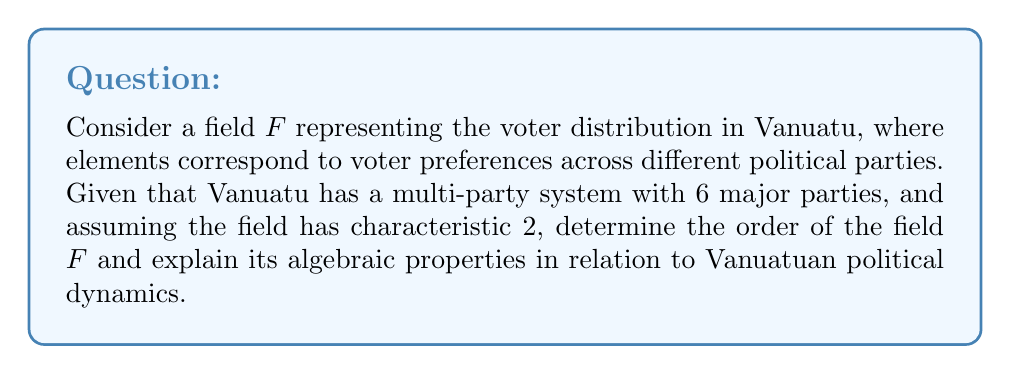What is the answer to this math problem? 1. In field theory, the order of a finite field is always a prime power. Given that the characteristic of the field is 2, the order must be of the form $2^n$.

2. With 6 major parties in Vanuatu, we need at least 6 elements to represent each party uniquely. The smallest power of 2 that accommodates this is $2^3 = 8$.

3. Therefore, the field $F$ is isomorphic to $GF(8)$, the Galois field of order 8.

4. Properties of $GF(8)$:
   a) It has 8 elements: $\{0, 1, \alpha, \alpha^2, \alpha^3, \alpha^4, \alpha^5, \alpha^6\}$, where $\alpha$ is a primitive element.
   b) The additive identity is 0, and the multiplicative identity is 1.
   c) Every non-zero element has a multiplicative inverse.
   d) Addition and multiplication are commutative, associative, and distributive.

5. Interpretation in Vanuatuan politics:
   a) Each element represents a distinct voter preference or coalition.
   b) The additive identity (0) could represent undecided voters.
   c) The multiplicative identity (1) could represent the status quo.
   d) The other elements ($\alpha, \alpha^2, ..., \alpha^6$) could represent the 6 major parties or combinations thereof.
   e) The field operations model how voter preferences combine or interact.

6. The characteristic being 2 implies that adding any element to itself results in 0, which could model the concept of vote cancellation or the instability of extreme political positions in Vanuatu's consensus-based political system.

7. The finite nature of the field reflects the limited number of viable political configurations in Vanuatu's multi-party system.
Answer: $GF(8)$ with order $2^3 = 8$ 